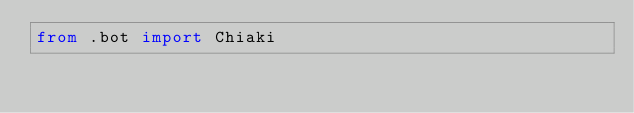Convert code to text. <code><loc_0><loc_0><loc_500><loc_500><_Python_>from .bot import Chiaki
</code> 